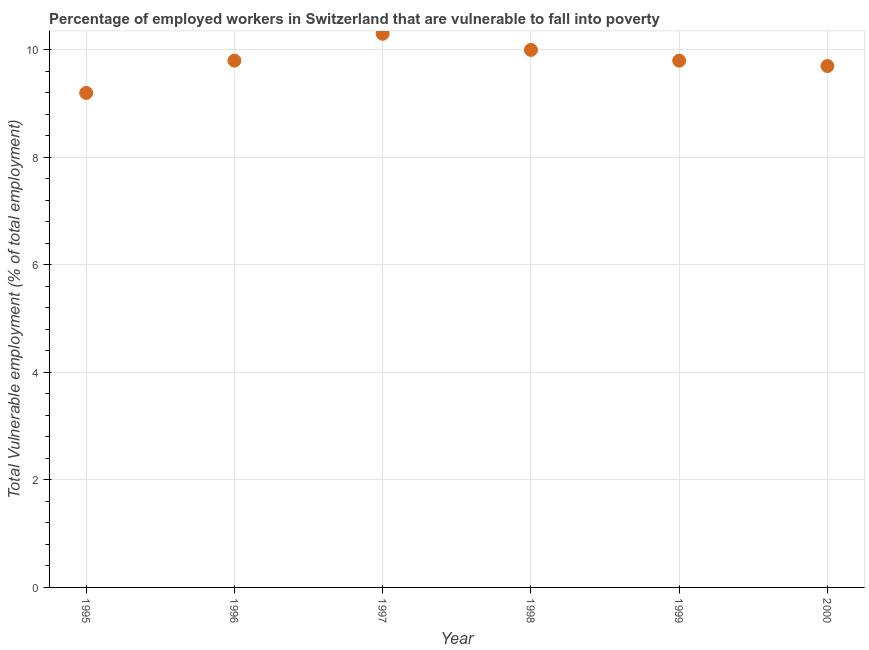What is the total vulnerable employment in 1997?
Make the answer very short. 10.3. Across all years, what is the maximum total vulnerable employment?
Your response must be concise. 10.3. Across all years, what is the minimum total vulnerable employment?
Provide a short and direct response. 9.2. In which year was the total vulnerable employment minimum?
Your answer should be compact. 1995. What is the sum of the total vulnerable employment?
Offer a very short reply. 58.8. What is the difference between the total vulnerable employment in 1996 and 1997?
Your answer should be compact. -0.5. What is the average total vulnerable employment per year?
Provide a succinct answer. 9.8. What is the median total vulnerable employment?
Give a very brief answer. 9.8. Do a majority of the years between 1998 and 1995 (inclusive) have total vulnerable employment greater than 9.2 %?
Give a very brief answer. Yes. What is the ratio of the total vulnerable employment in 1997 to that in 1999?
Offer a terse response. 1.05. Is the total vulnerable employment in 1998 less than that in 1999?
Make the answer very short. No. What is the difference between the highest and the second highest total vulnerable employment?
Your answer should be compact. 0.3. Is the sum of the total vulnerable employment in 1995 and 1998 greater than the maximum total vulnerable employment across all years?
Offer a very short reply. Yes. What is the difference between the highest and the lowest total vulnerable employment?
Keep it short and to the point. 1.1. Does the total vulnerable employment monotonically increase over the years?
Your response must be concise. No. What is the difference between two consecutive major ticks on the Y-axis?
Keep it short and to the point. 2. Does the graph contain grids?
Make the answer very short. Yes. What is the title of the graph?
Your answer should be very brief. Percentage of employed workers in Switzerland that are vulnerable to fall into poverty. What is the label or title of the X-axis?
Keep it short and to the point. Year. What is the label or title of the Y-axis?
Your answer should be very brief. Total Vulnerable employment (% of total employment). What is the Total Vulnerable employment (% of total employment) in 1995?
Offer a terse response. 9.2. What is the Total Vulnerable employment (% of total employment) in 1996?
Your answer should be compact. 9.8. What is the Total Vulnerable employment (% of total employment) in 1997?
Offer a terse response. 10.3. What is the Total Vulnerable employment (% of total employment) in 1998?
Ensure brevity in your answer.  10. What is the Total Vulnerable employment (% of total employment) in 1999?
Make the answer very short. 9.8. What is the Total Vulnerable employment (% of total employment) in 2000?
Your response must be concise. 9.7. What is the difference between the Total Vulnerable employment (% of total employment) in 1995 and 1996?
Your answer should be very brief. -0.6. What is the difference between the Total Vulnerable employment (% of total employment) in 1995 and 1999?
Provide a succinct answer. -0.6. What is the difference between the Total Vulnerable employment (% of total employment) in 1996 and 1997?
Offer a very short reply. -0.5. What is the difference between the Total Vulnerable employment (% of total employment) in 1996 and 2000?
Provide a succinct answer. 0.1. What is the difference between the Total Vulnerable employment (% of total employment) in 1997 and 1998?
Give a very brief answer. 0.3. What is the difference between the Total Vulnerable employment (% of total employment) in 1997 and 1999?
Keep it short and to the point. 0.5. What is the difference between the Total Vulnerable employment (% of total employment) in 1998 and 2000?
Provide a succinct answer. 0.3. What is the ratio of the Total Vulnerable employment (% of total employment) in 1995 to that in 1996?
Make the answer very short. 0.94. What is the ratio of the Total Vulnerable employment (% of total employment) in 1995 to that in 1997?
Give a very brief answer. 0.89. What is the ratio of the Total Vulnerable employment (% of total employment) in 1995 to that in 1998?
Keep it short and to the point. 0.92. What is the ratio of the Total Vulnerable employment (% of total employment) in 1995 to that in 1999?
Provide a succinct answer. 0.94. What is the ratio of the Total Vulnerable employment (% of total employment) in 1995 to that in 2000?
Ensure brevity in your answer.  0.95. What is the ratio of the Total Vulnerable employment (% of total employment) in 1996 to that in 1997?
Give a very brief answer. 0.95. What is the ratio of the Total Vulnerable employment (% of total employment) in 1996 to that in 1999?
Make the answer very short. 1. What is the ratio of the Total Vulnerable employment (% of total employment) in 1997 to that in 1999?
Give a very brief answer. 1.05. What is the ratio of the Total Vulnerable employment (% of total employment) in 1997 to that in 2000?
Your response must be concise. 1.06. What is the ratio of the Total Vulnerable employment (% of total employment) in 1998 to that in 1999?
Offer a terse response. 1.02. What is the ratio of the Total Vulnerable employment (% of total employment) in 1998 to that in 2000?
Provide a short and direct response. 1.03. 